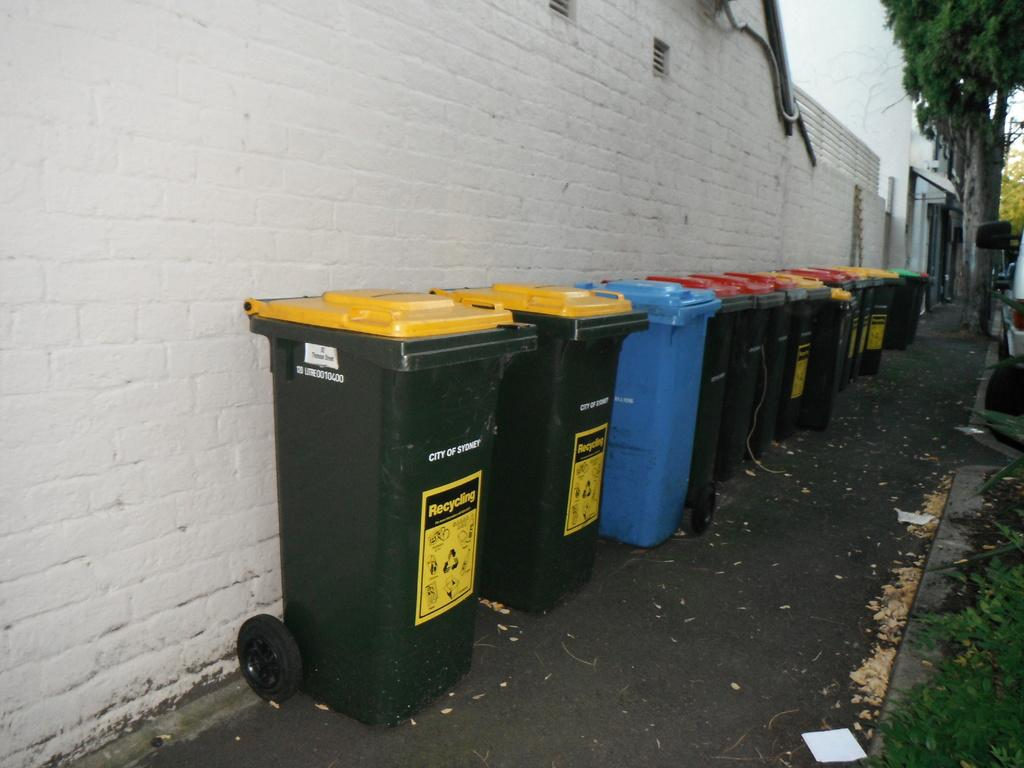<image>
Give a short and clear explanation of the subsequent image. A row of bins, the nearest of which has City of Sydney on it. 